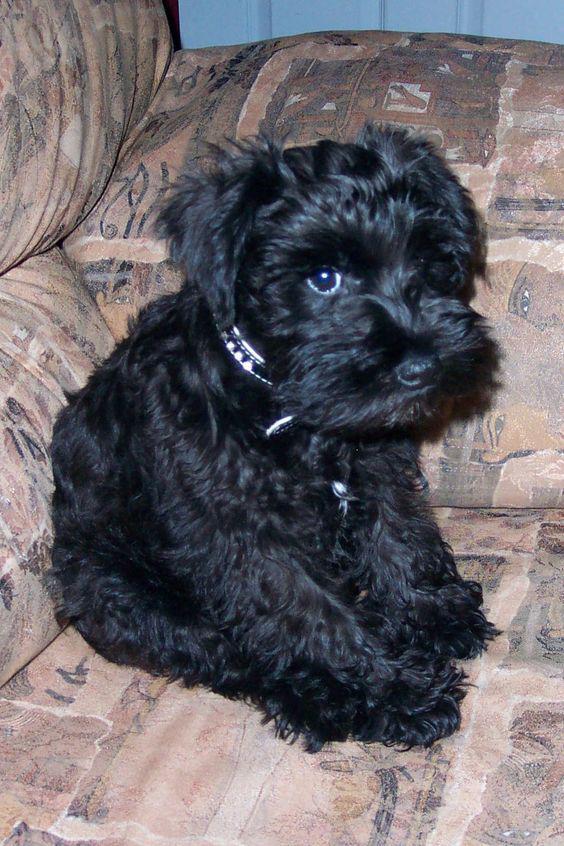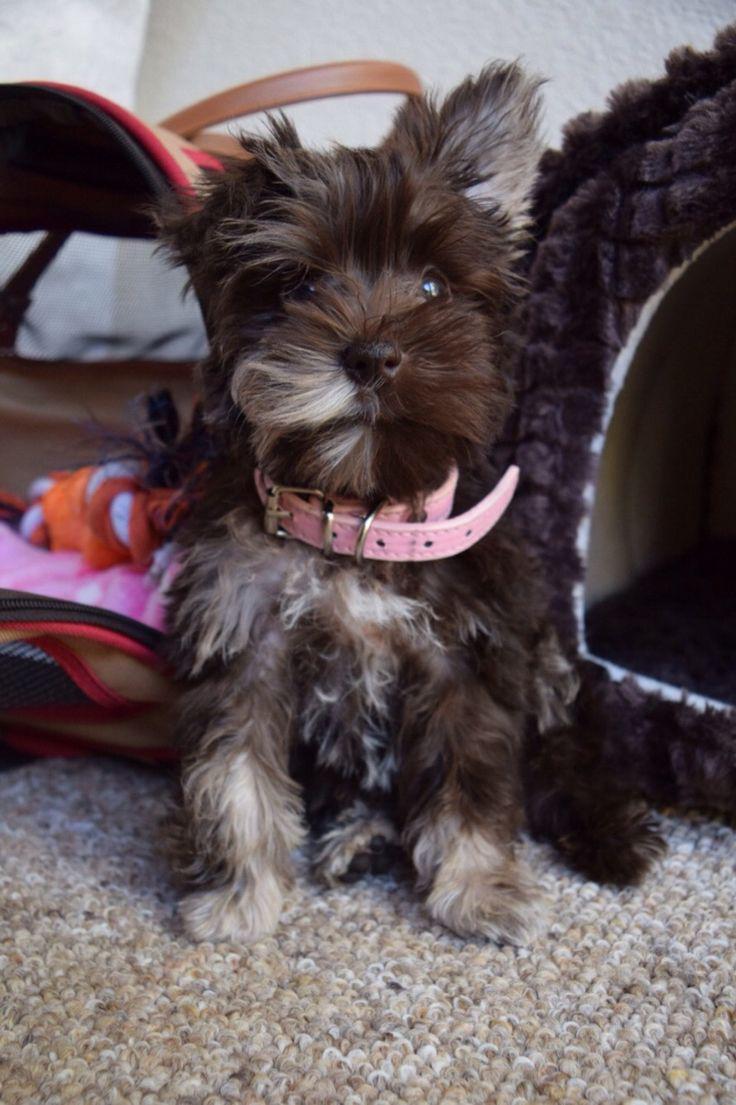The first image is the image on the left, the second image is the image on the right. Assess this claim about the two images: "An image shows a frontward-facing schnauzer wearing a collar.". Correct or not? Answer yes or no. Yes. The first image is the image on the left, the second image is the image on the right. For the images shown, is this caption "Two dogs are sitting down and looking at the camera." true? Answer yes or no. Yes. 